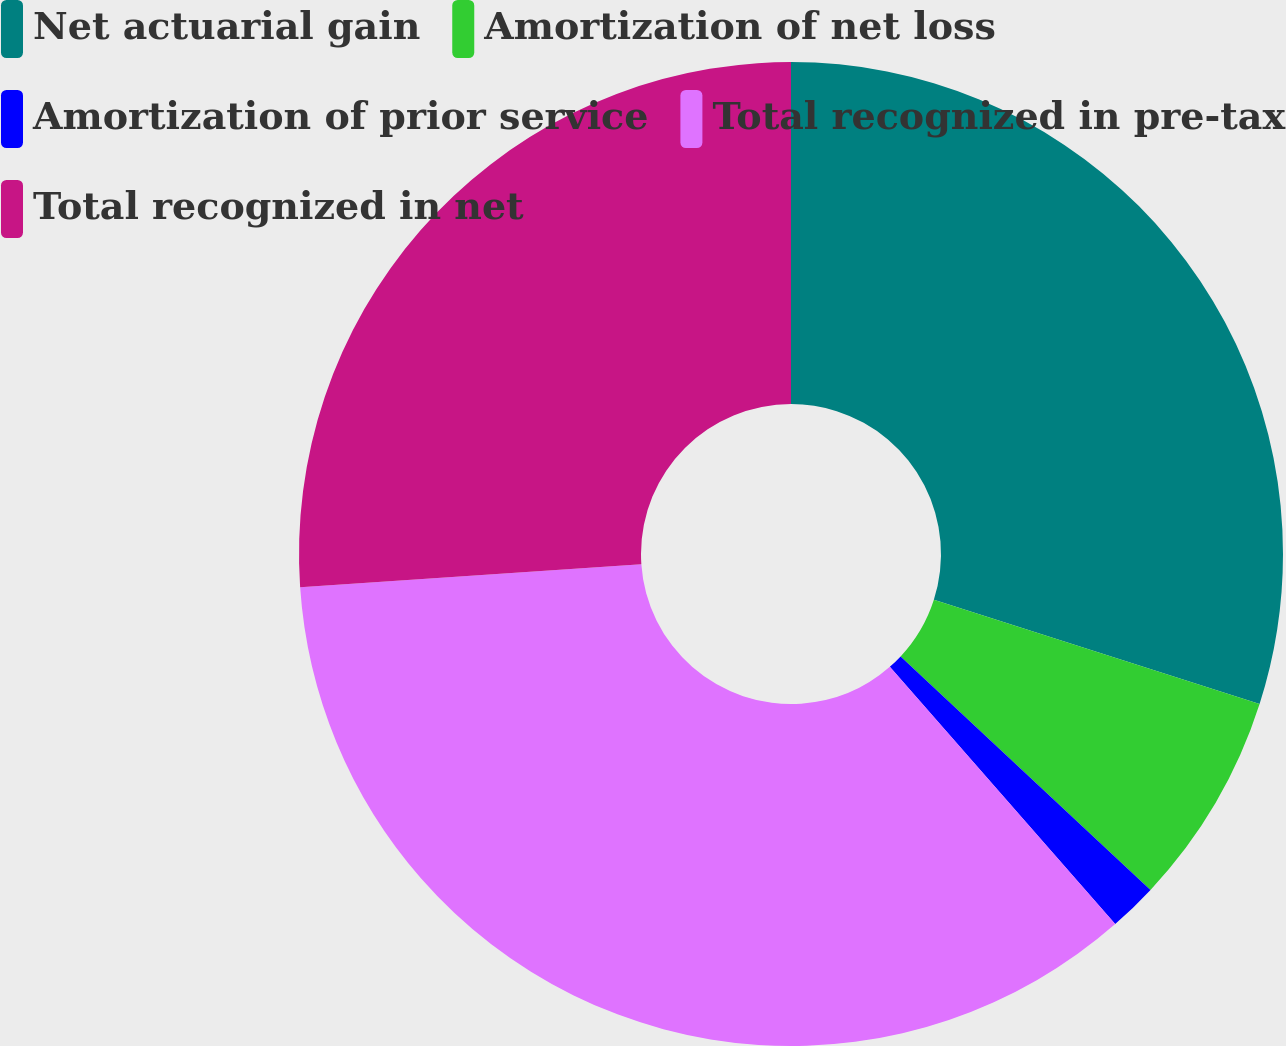Convert chart. <chart><loc_0><loc_0><loc_500><loc_500><pie_chart><fcel>Net actuarial gain<fcel>Amortization of net loss<fcel>Amortization of prior service<fcel>Total recognized in pre-tax<fcel>Total recognized in net<nl><fcel>29.93%<fcel>7.03%<fcel>1.59%<fcel>35.37%<fcel>26.08%<nl></chart> 